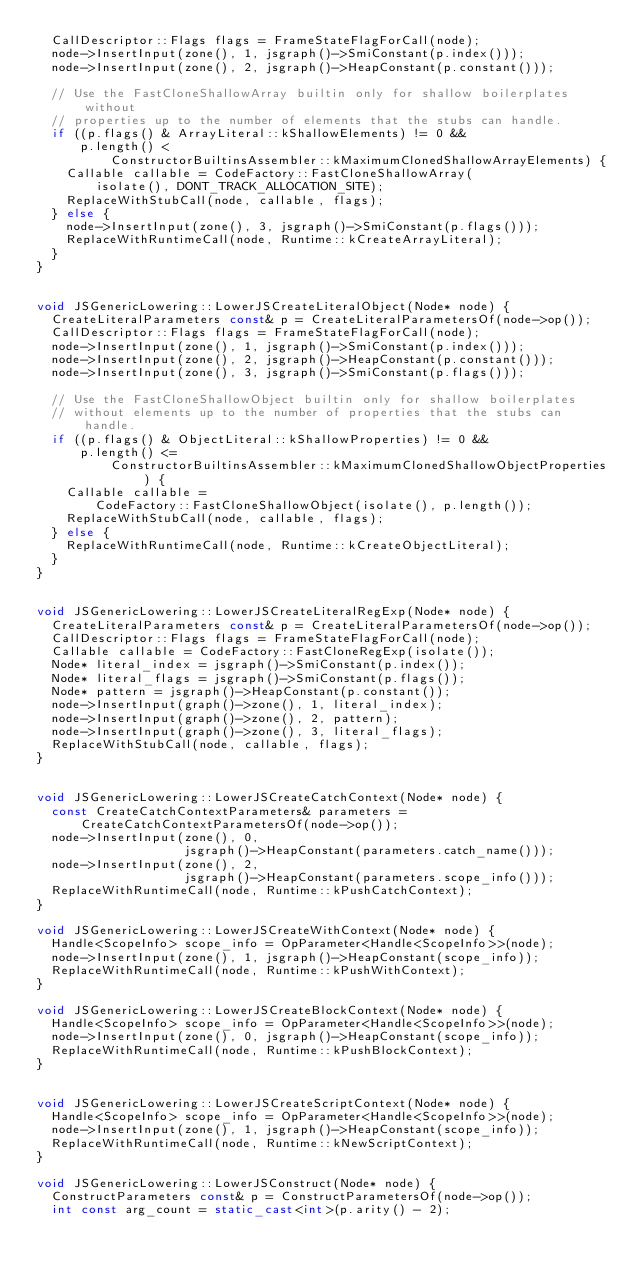Convert code to text. <code><loc_0><loc_0><loc_500><loc_500><_C++_>  CallDescriptor::Flags flags = FrameStateFlagForCall(node);
  node->InsertInput(zone(), 1, jsgraph()->SmiConstant(p.index()));
  node->InsertInput(zone(), 2, jsgraph()->HeapConstant(p.constant()));

  // Use the FastCloneShallowArray builtin only for shallow boilerplates without
  // properties up to the number of elements that the stubs can handle.
  if ((p.flags() & ArrayLiteral::kShallowElements) != 0 &&
      p.length() <
          ConstructorBuiltinsAssembler::kMaximumClonedShallowArrayElements) {
    Callable callable = CodeFactory::FastCloneShallowArray(
        isolate(), DONT_TRACK_ALLOCATION_SITE);
    ReplaceWithStubCall(node, callable, flags);
  } else {
    node->InsertInput(zone(), 3, jsgraph()->SmiConstant(p.flags()));
    ReplaceWithRuntimeCall(node, Runtime::kCreateArrayLiteral);
  }
}


void JSGenericLowering::LowerJSCreateLiteralObject(Node* node) {
  CreateLiteralParameters const& p = CreateLiteralParametersOf(node->op());
  CallDescriptor::Flags flags = FrameStateFlagForCall(node);
  node->InsertInput(zone(), 1, jsgraph()->SmiConstant(p.index()));
  node->InsertInput(zone(), 2, jsgraph()->HeapConstant(p.constant()));
  node->InsertInput(zone(), 3, jsgraph()->SmiConstant(p.flags()));

  // Use the FastCloneShallowObject builtin only for shallow boilerplates
  // without elements up to the number of properties that the stubs can handle.
  if ((p.flags() & ObjectLiteral::kShallowProperties) != 0 &&
      p.length() <=
          ConstructorBuiltinsAssembler::kMaximumClonedShallowObjectProperties) {
    Callable callable =
        CodeFactory::FastCloneShallowObject(isolate(), p.length());
    ReplaceWithStubCall(node, callable, flags);
  } else {
    ReplaceWithRuntimeCall(node, Runtime::kCreateObjectLiteral);
  }
}


void JSGenericLowering::LowerJSCreateLiteralRegExp(Node* node) {
  CreateLiteralParameters const& p = CreateLiteralParametersOf(node->op());
  CallDescriptor::Flags flags = FrameStateFlagForCall(node);
  Callable callable = CodeFactory::FastCloneRegExp(isolate());
  Node* literal_index = jsgraph()->SmiConstant(p.index());
  Node* literal_flags = jsgraph()->SmiConstant(p.flags());
  Node* pattern = jsgraph()->HeapConstant(p.constant());
  node->InsertInput(graph()->zone(), 1, literal_index);
  node->InsertInput(graph()->zone(), 2, pattern);
  node->InsertInput(graph()->zone(), 3, literal_flags);
  ReplaceWithStubCall(node, callable, flags);
}


void JSGenericLowering::LowerJSCreateCatchContext(Node* node) {
  const CreateCatchContextParameters& parameters =
      CreateCatchContextParametersOf(node->op());
  node->InsertInput(zone(), 0,
                    jsgraph()->HeapConstant(parameters.catch_name()));
  node->InsertInput(zone(), 2,
                    jsgraph()->HeapConstant(parameters.scope_info()));
  ReplaceWithRuntimeCall(node, Runtime::kPushCatchContext);
}

void JSGenericLowering::LowerJSCreateWithContext(Node* node) {
  Handle<ScopeInfo> scope_info = OpParameter<Handle<ScopeInfo>>(node);
  node->InsertInput(zone(), 1, jsgraph()->HeapConstant(scope_info));
  ReplaceWithRuntimeCall(node, Runtime::kPushWithContext);
}

void JSGenericLowering::LowerJSCreateBlockContext(Node* node) {
  Handle<ScopeInfo> scope_info = OpParameter<Handle<ScopeInfo>>(node);
  node->InsertInput(zone(), 0, jsgraph()->HeapConstant(scope_info));
  ReplaceWithRuntimeCall(node, Runtime::kPushBlockContext);
}


void JSGenericLowering::LowerJSCreateScriptContext(Node* node) {
  Handle<ScopeInfo> scope_info = OpParameter<Handle<ScopeInfo>>(node);
  node->InsertInput(zone(), 1, jsgraph()->HeapConstant(scope_info));
  ReplaceWithRuntimeCall(node, Runtime::kNewScriptContext);
}

void JSGenericLowering::LowerJSConstruct(Node* node) {
  ConstructParameters const& p = ConstructParametersOf(node->op());
  int const arg_count = static_cast<int>(p.arity() - 2);</code> 